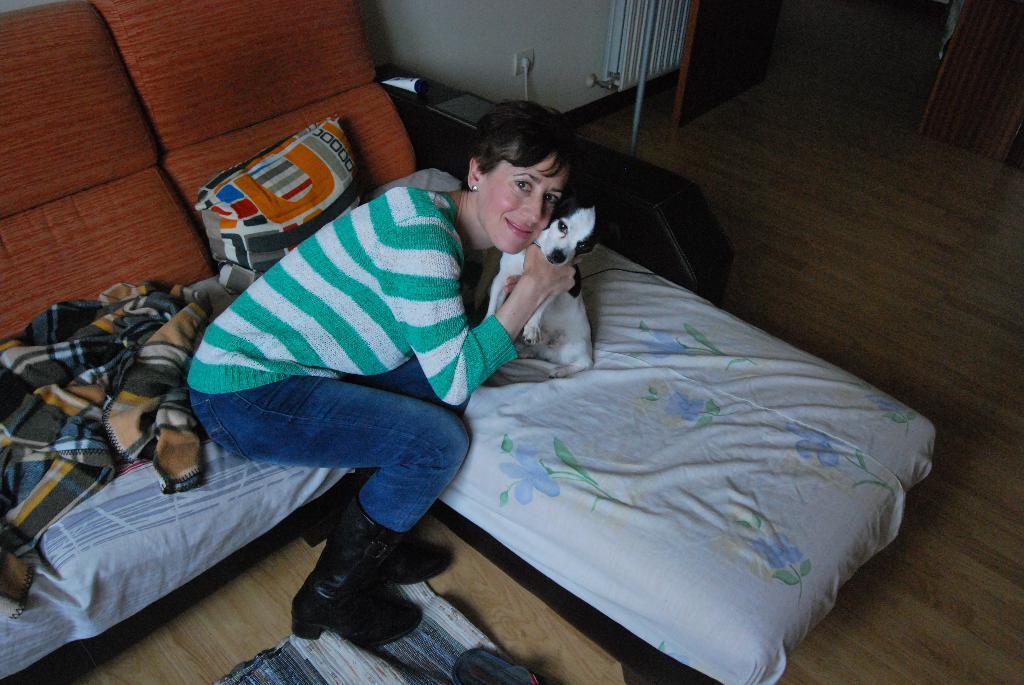How would you summarize this image in a sentence or two? In this Image I see a woman who is sitting on the couch and she is holding a dog in her hands. I can also see she is smiling and In the background I see the wall and the door. 